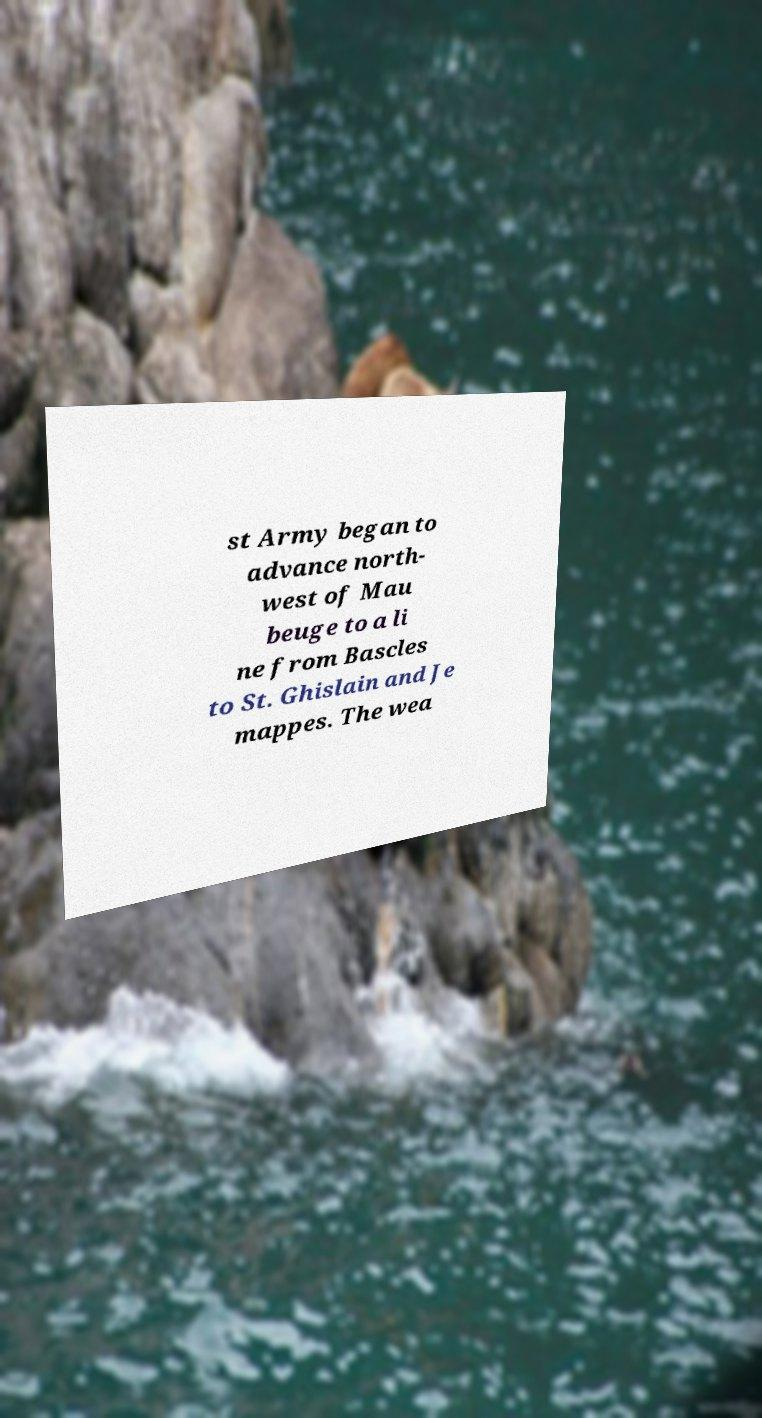Please read and relay the text visible in this image. What does it say? st Army began to advance north- west of Mau beuge to a li ne from Bascles to St. Ghislain and Je mappes. The wea 